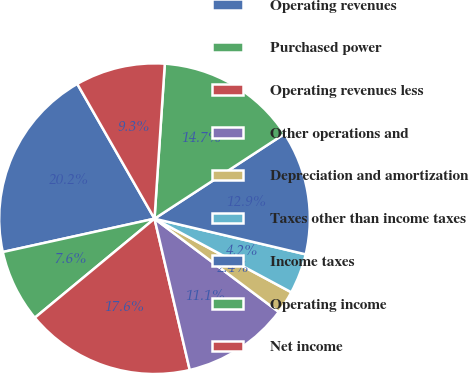Convert chart. <chart><loc_0><loc_0><loc_500><loc_500><pie_chart><fcel>Operating revenues<fcel>Purchased power<fcel>Operating revenues less<fcel>Other operations and<fcel>Depreciation and amortization<fcel>Taxes other than income taxes<fcel>Income taxes<fcel>Operating income<fcel>Net income<nl><fcel>20.16%<fcel>7.56%<fcel>17.64%<fcel>11.11%<fcel>2.39%<fcel>4.17%<fcel>12.89%<fcel>14.74%<fcel>9.34%<nl></chart> 